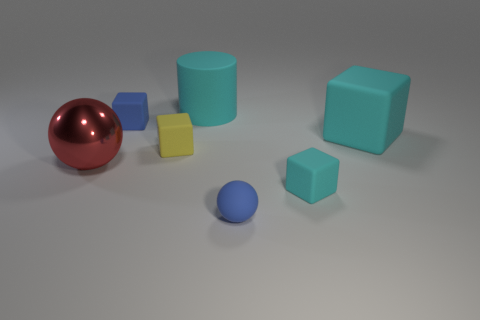Can you describe the materials of the objects in the image? Certainly! The image displays various objects with distinct materials and finishes. The spherical object has a reflective, shiny surface indicating it could be made of polished metal. The cylinders and cubes exhibit a matte finish, suggestive of rubber or plastic material. Their surfaces don't reflect light and have a softer look compared to the metal sphere. How does the lighting affect the appearance of the materials? The lighting in the scene is soft and diffused, casting gentle shadows and subtly highlighting the material characteristics of each object. The reflective surface of the metal sphere shows off a mirrored image of the environment, whereas the matte rubber or plastic objects absorb the light, showcasing their textured surfaces without any significant reflection. 